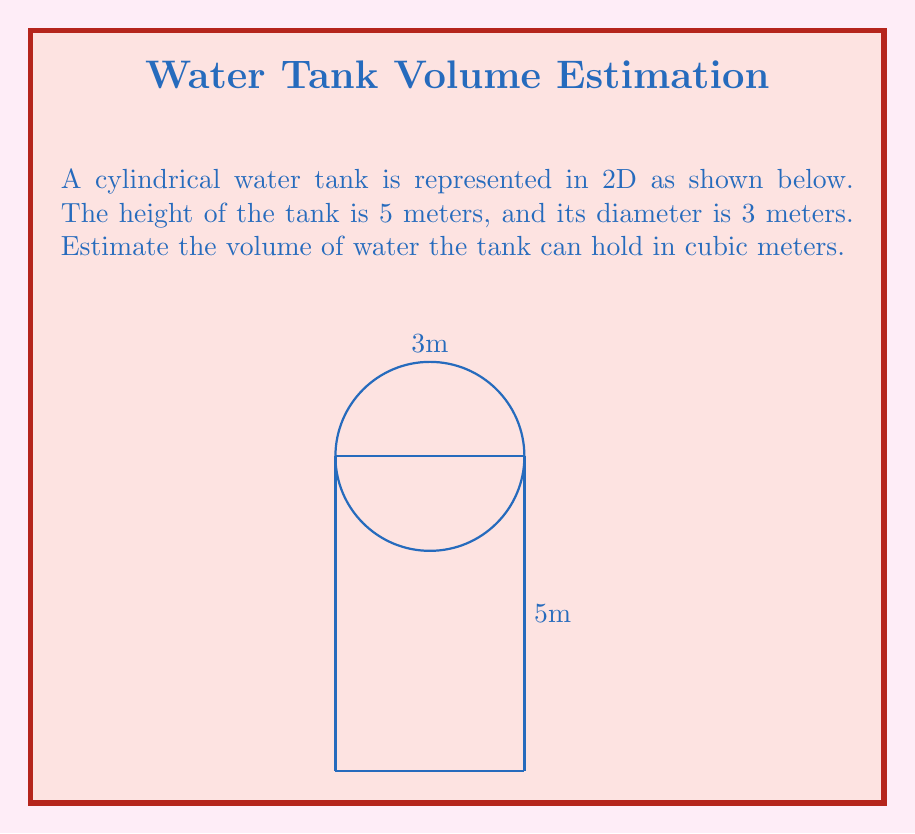What is the answer to this math problem? To estimate the volume of the cylindrical water tank:

1) Recall the formula for the volume of a cylinder:
   $$V = \pi r^2 h$$
   where $r$ is the radius and $h$ is the height.

2) Given:
   - Diameter = 3 meters
   - Height = 5 meters

3) Calculate the radius:
   $$r = \frac{\text{diameter}}{2} = \frac{3}{2} = 1.5 \text{ meters}$$

4) Substitute the values into the volume formula:
   $$V = \pi (1.5)^2 (5)$$

5) Calculate:
   $$V = \pi (2.25) (5) = 11.25\pi \approx 35.34 \text{ cubic meters}$$

6) Round to the nearest whole number for an estimate:
   $$V \approx 35 \text{ cubic meters}$$
Answer: $35 \text{ m}^3$ 